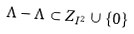<formula> <loc_0><loc_0><loc_500><loc_500>\Lambda - \Lambda \subset Z _ { I ^ { 2 } } \cup \left \{ 0 \right \}</formula> 